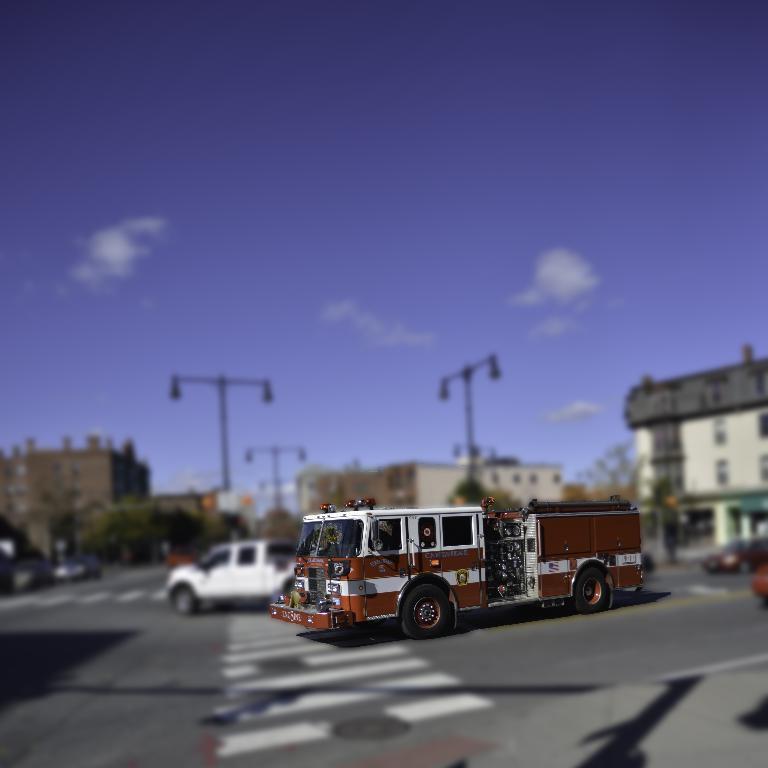Can you describe this image briefly? In this image, we can see a vehicle on the road. Background we can see a blur view. Here we can see vehicles, poles, trees, buildings. Here there is a sky. 